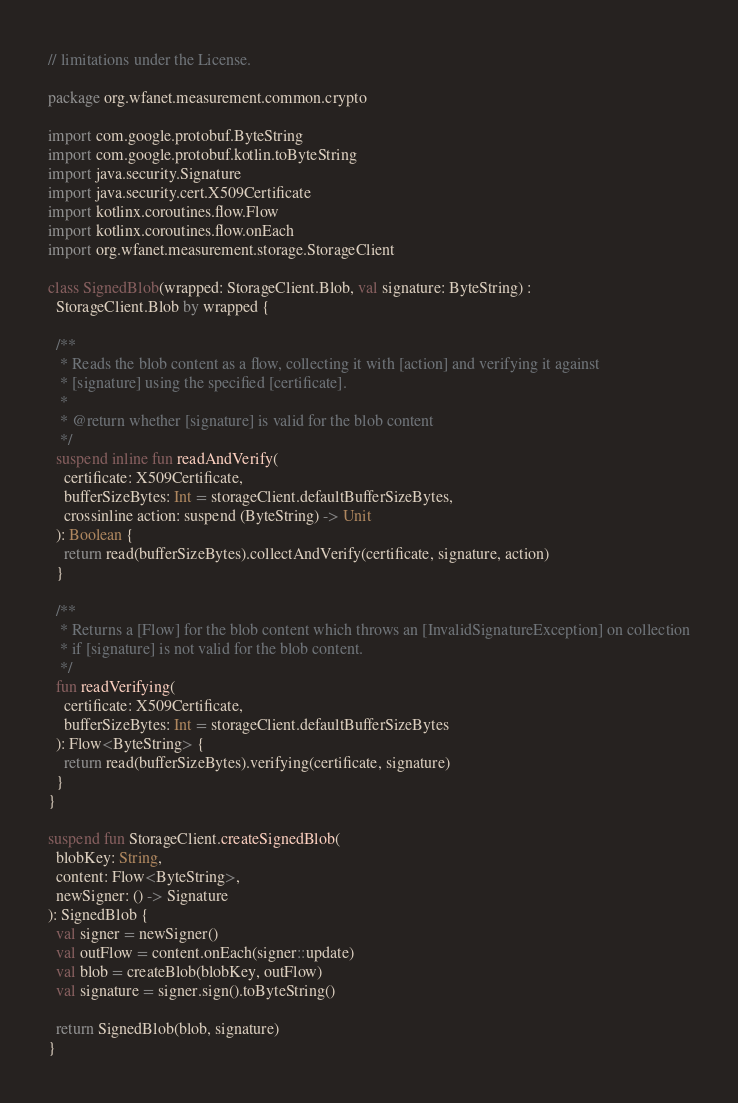Convert code to text. <code><loc_0><loc_0><loc_500><loc_500><_Kotlin_>// limitations under the License.

package org.wfanet.measurement.common.crypto

import com.google.protobuf.ByteString
import com.google.protobuf.kotlin.toByteString
import java.security.Signature
import java.security.cert.X509Certificate
import kotlinx.coroutines.flow.Flow
import kotlinx.coroutines.flow.onEach
import org.wfanet.measurement.storage.StorageClient

class SignedBlob(wrapped: StorageClient.Blob, val signature: ByteString) :
  StorageClient.Blob by wrapped {

  /**
   * Reads the blob content as a flow, collecting it with [action] and verifying it against
   * [signature] using the specified [certificate].
   *
   * @return whether [signature] is valid for the blob content
   */
  suspend inline fun readAndVerify(
    certificate: X509Certificate,
    bufferSizeBytes: Int = storageClient.defaultBufferSizeBytes,
    crossinline action: suspend (ByteString) -> Unit
  ): Boolean {
    return read(bufferSizeBytes).collectAndVerify(certificate, signature, action)
  }

  /**
   * Returns a [Flow] for the blob content which throws an [InvalidSignatureException] on collection
   * if [signature] is not valid for the blob content.
   */
  fun readVerifying(
    certificate: X509Certificate,
    bufferSizeBytes: Int = storageClient.defaultBufferSizeBytes
  ): Flow<ByteString> {
    return read(bufferSizeBytes).verifying(certificate, signature)
  }
}

suspend fun StorageClient.createSignedBlob(
  blobKey: String,
  content: Flow<ByteString>,
  newSigner: () -> Signature
): SignedBlob {
  val signer = newSigner()
  val outFlow = content.onEach(signer::update)
  val blob = createBlob(blobKey, outFlow)
  val signature = signer.sign().toByteString()

  return SignedBlob(blob, signature)
}
</code> 